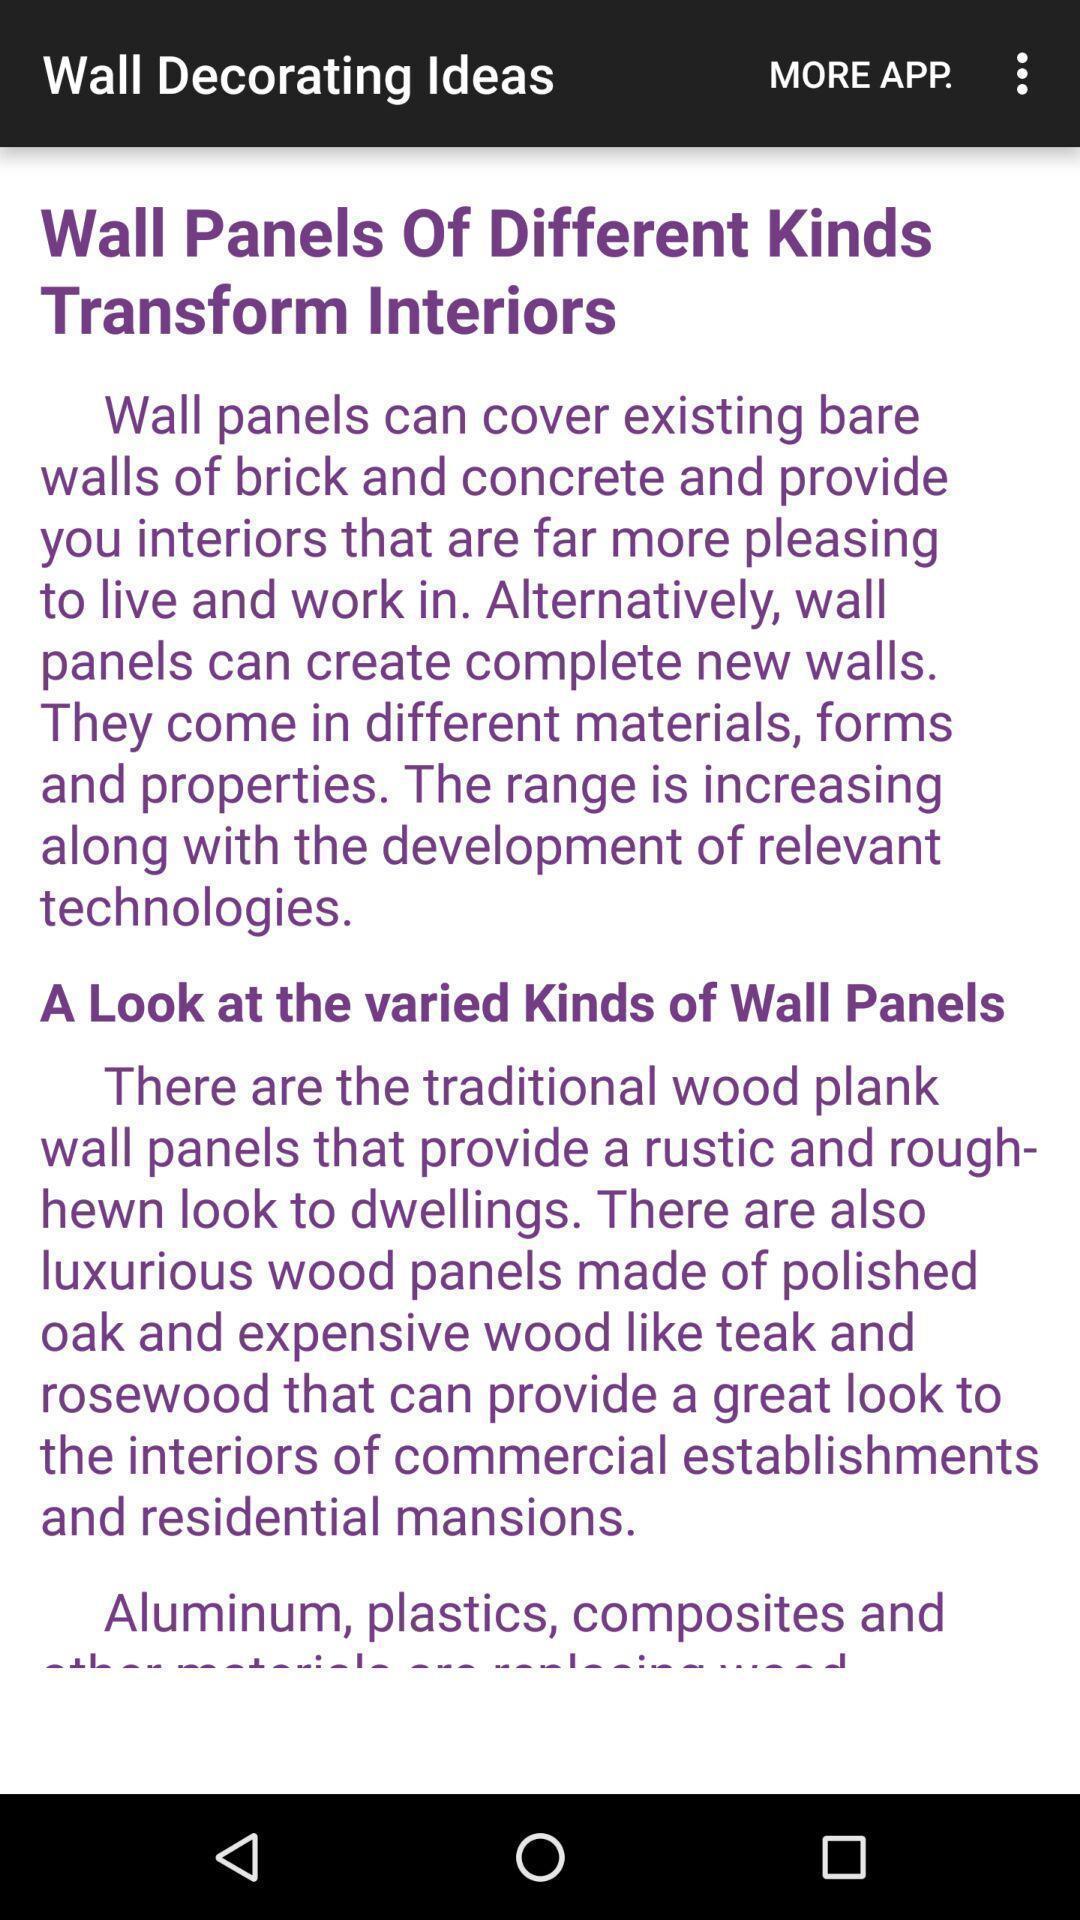What details can you identify in this image? Various info regarding decoration ideas displayed. 